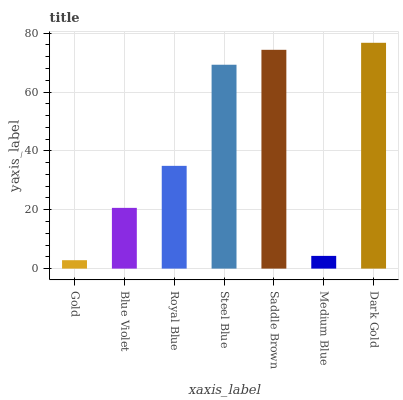Is Gold the minimum?
Answer yes or no. Yes. Is Dark Gold the maximum?
Answer yes or no. Yes. Is Blue Violet the minimum?
Answer yes or no. No. Is Blue Violet the maximum?
Answer yes or no. No. Is Blue Violet greater than Gold?
Answer yes or no. Yes. Is Gold less than Blue Violet?
Answer yes or no. Yes. Is Gold greater than Blue Violet?
Answer yes or no. No. Is Blue Violet less than Gold?
Answer yes or no. No. Is Royal Blue the high median?
Answer yes or no. Yes. Is Royal Blue the low median?
Answer yes or no. Yes. Is Medium Blue the high median?
Answer yes or no. No. Is Saddle Brown the low median?
Answer yes or no. No. 